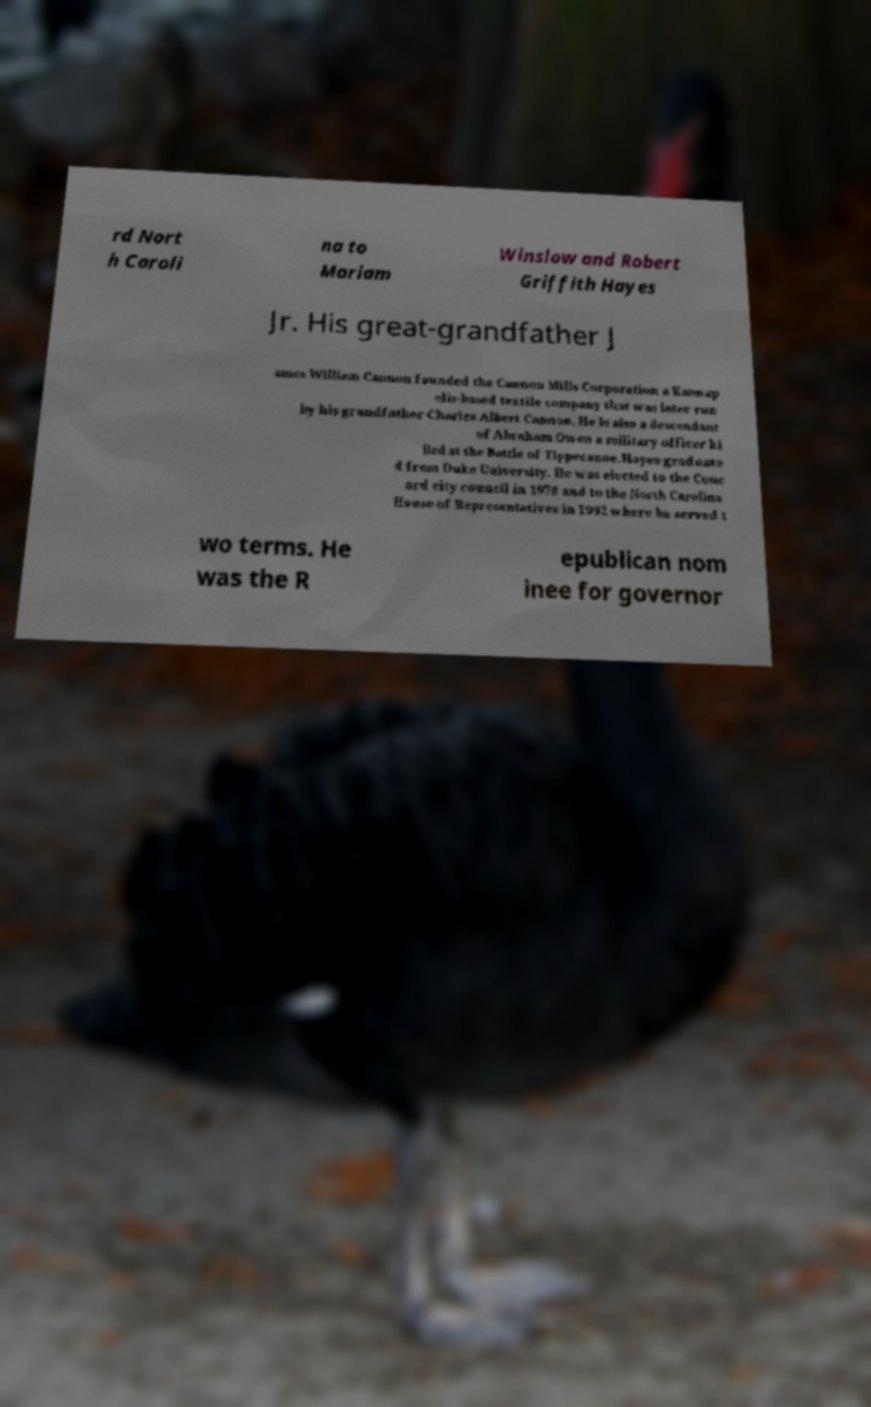There's text embedded in this image that I need extracted. Can you transcribe it verbatim? rd Nort h Caroli na to Mariam Winslow and Robert Griffith Hayes Jr. His great-grandfather J ames William Cannon founded the Cannon Mills Corporation a Kannap olis-based textile company that was later run by his grandfather Charles Albert Cannon. He is also a descendant of Abraham Owen a military officer ki lled at the Battle of Tippecanoe.Hayes graduate d from Duke University. He was elected to the Conc ord city council in 1978 and to the North Carolina House of Representatives in 1992 where he served t wo terms. He was the R epublican nom inee for governor 